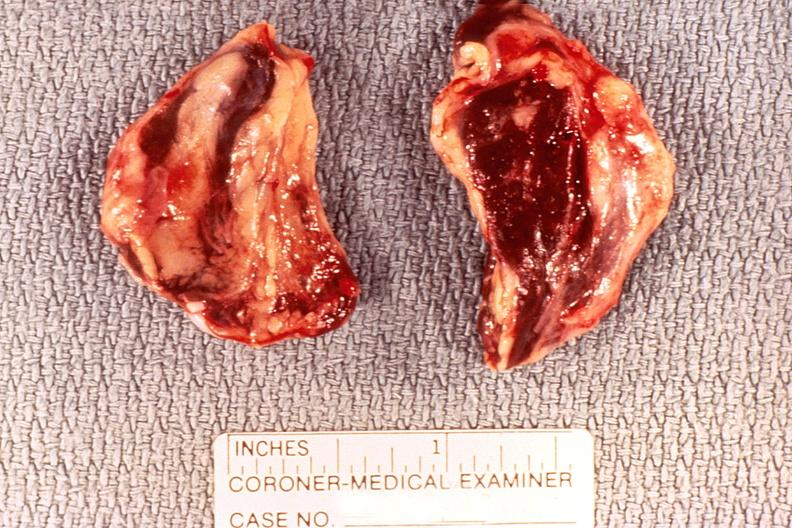s case of peritonitis slide present?
Answer the question using a single word or phrase. No 